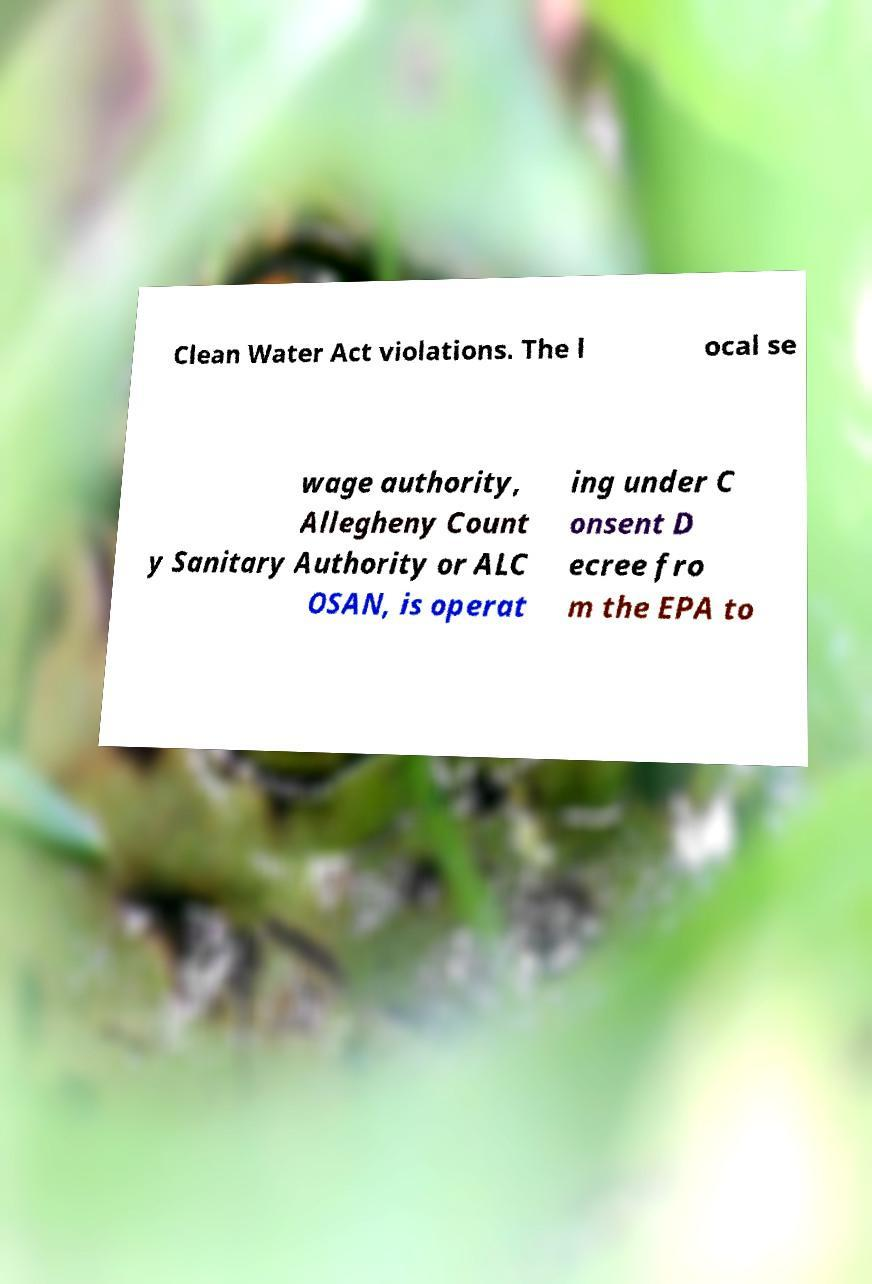Could you extract and type out the text from this image? Clean Water Act violations. The l ocal se wage authority, Allegheny Count y Sanitary Authority or ALC OSAN, is operat ing under C onsent D ecree fro m the EPA to 